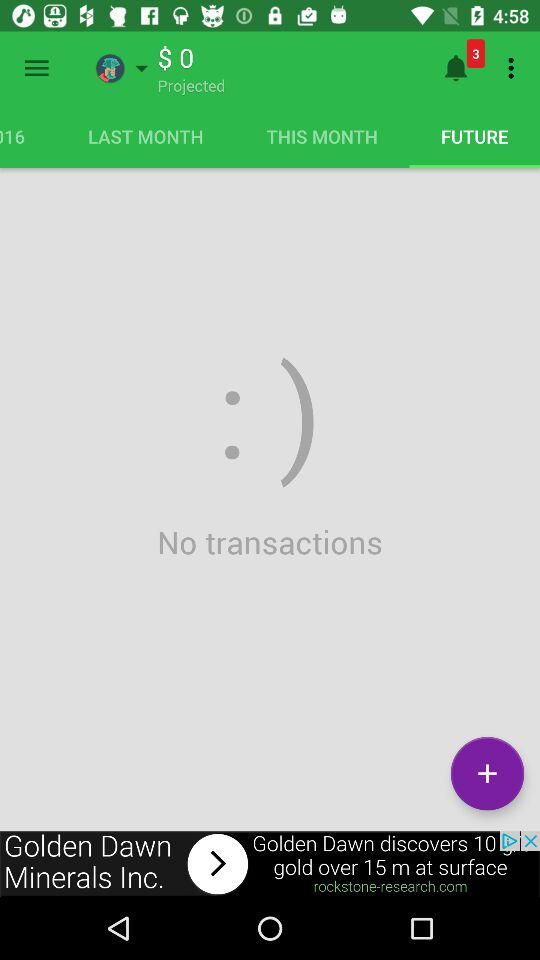How many transactions have not been completed?
Answer the question using a single word or phrase. 0 